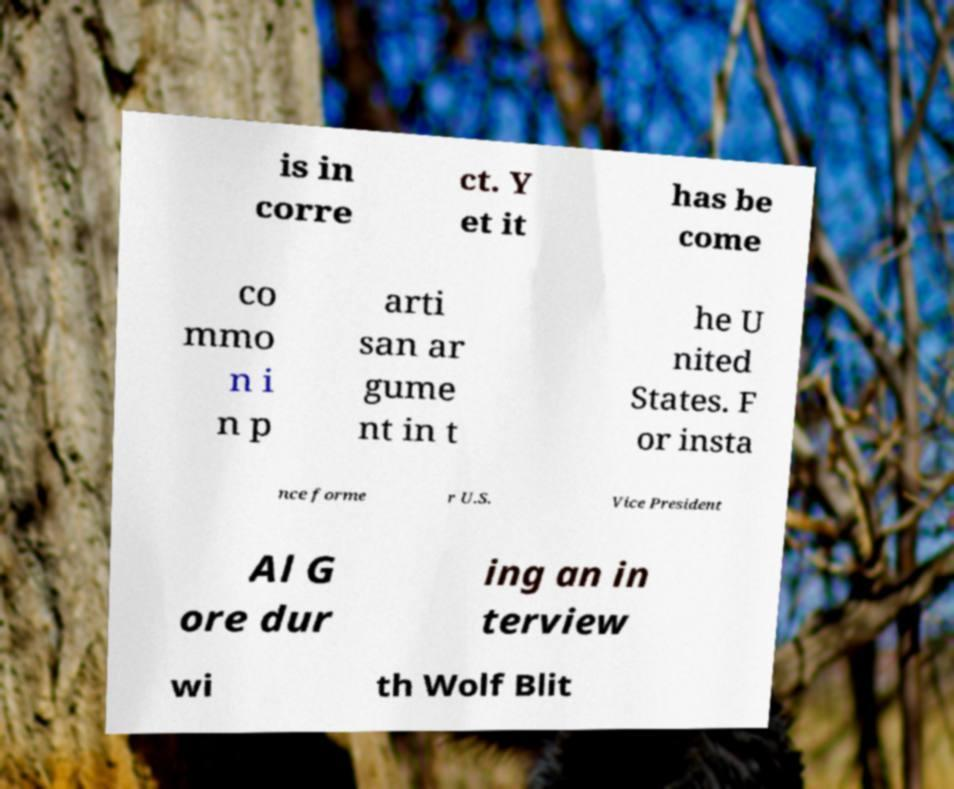Could you extract and type out the text from this image? is in corre ct. Y et it has be come co mmo n i n p arti san ar gume nt in t he U nited States. F or insta nce forme r U.S. Vice President Al G ore dur ing an in terview wi th Wolf Blit 